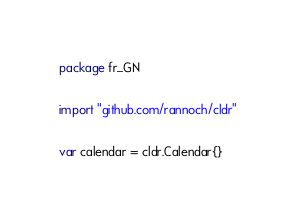<code> <loc_0><loc_0><loc_500><loc_500><_Go_>package fr_GN

import "github.com/rannoch/cldr"

var calendar = cldr.Calendar{}
</code> 